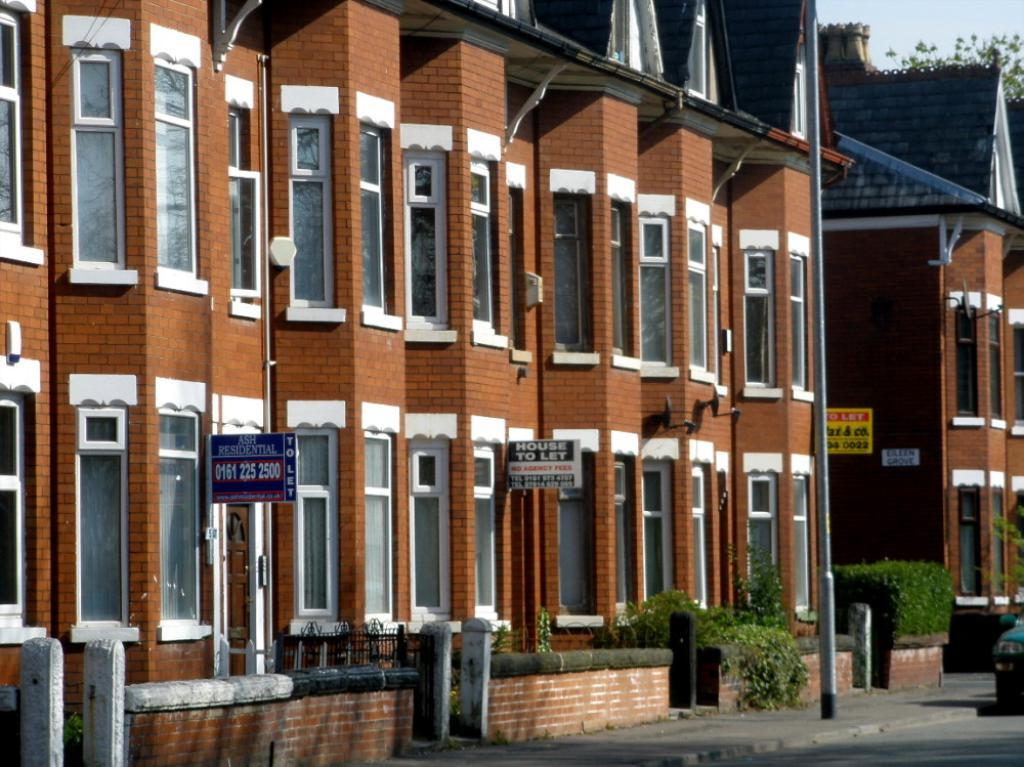What type of structure is present in the image? There is a building in the image. What colors can be seen on the building? The building has white and brown colors. What is attached to the building? There are boards attached to the building. What type of vegetation is present in the image? There are plants in the image. What is the color of the plants? The plants are green. What is visible in the background of the image? The sky is visible in the image. What is the color of the sky? The sky has a white color. How many patches are visible on the building in the image? There is no mention of patches in the provided facts, so we cannot determine the number of patches on the building. Is there a gun visible in the image? There is no mention of a gun in the provided facts, so we cannot determine if a gun is visible in the image. 